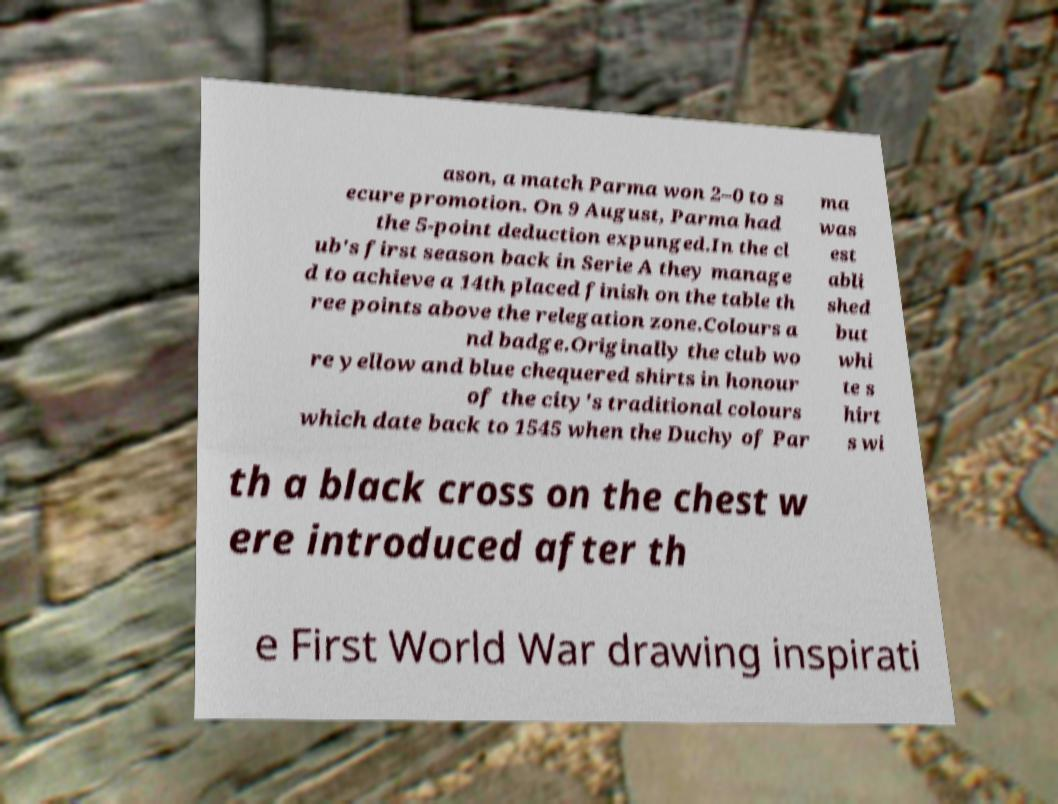Can you read and provide the text displayed in the image?This photo seems to have some interesting text. Can you extract and type it out for me? ason, a match Parma won 2–0 to s ecure promotion. On 9 August, Parma had the 5-point deduction expunged.In the cl ub's first season back in Serie A they manage d to achieve a 14th placed finish on the table th ree points above the relegation zone.Colours a nd badge.Originally the club wo re yellow and blue chequered shirts in honour of the city's traditional colours which date back to 1545 when the Duchy of Par ma was est abli shed but whi te s hirt s wi th a black cross on the chest w ere introduced after th e First World War drawing inspirati 